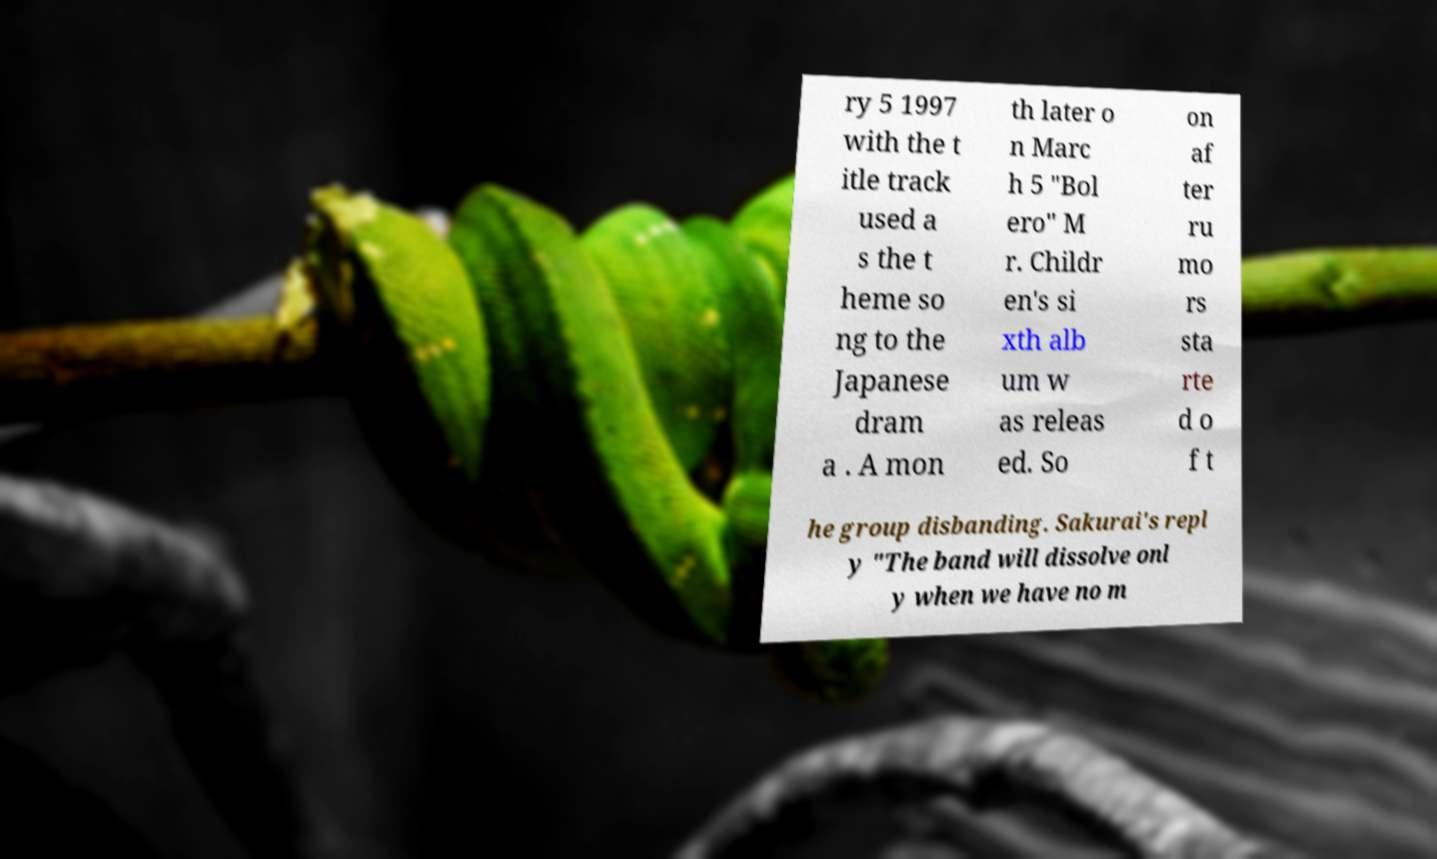Please identify and transcribe the text found in this image. ry 5 1997 with the t itle track used a s the t heme so ng to the Japanese dram a . A mon th later o n Marc h 5 "Bol ero" M r. Childr en's si xth alb um w as releas ed. So on af ter ru mo rs sta rte d o f t he group disbanding. Sakurai's repl y "The band will dissolve onl y when we have no m 